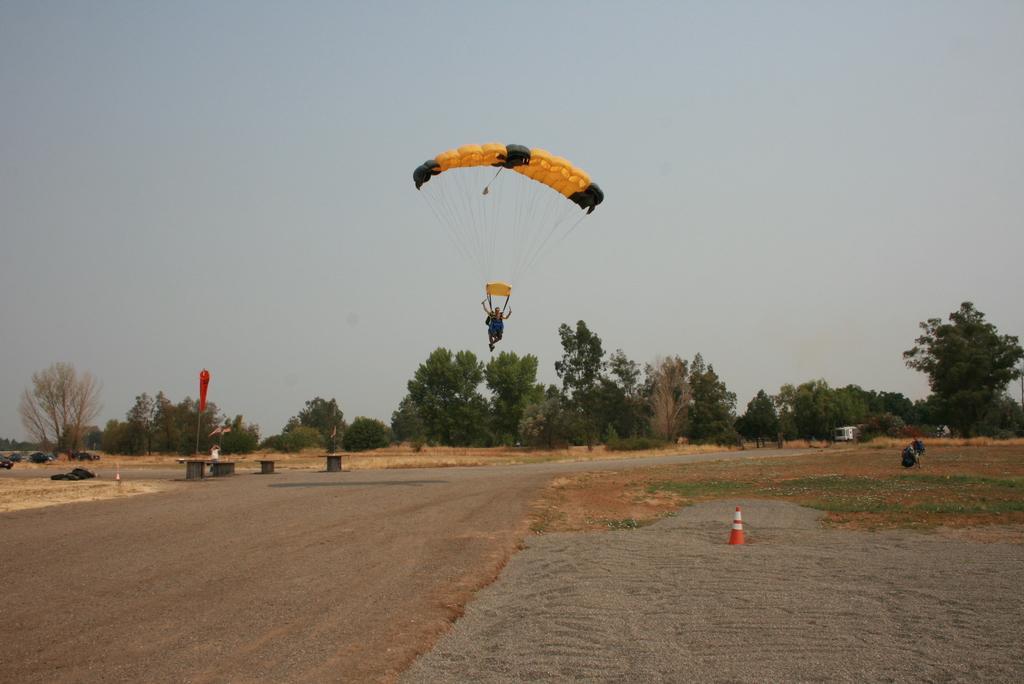Describe this image in one or two sentences. In this picture there is a person paragliding in the air and we can see traffic cone on the ground, grass, vehicles and objects. In the background of the image we can see trees and sky. 